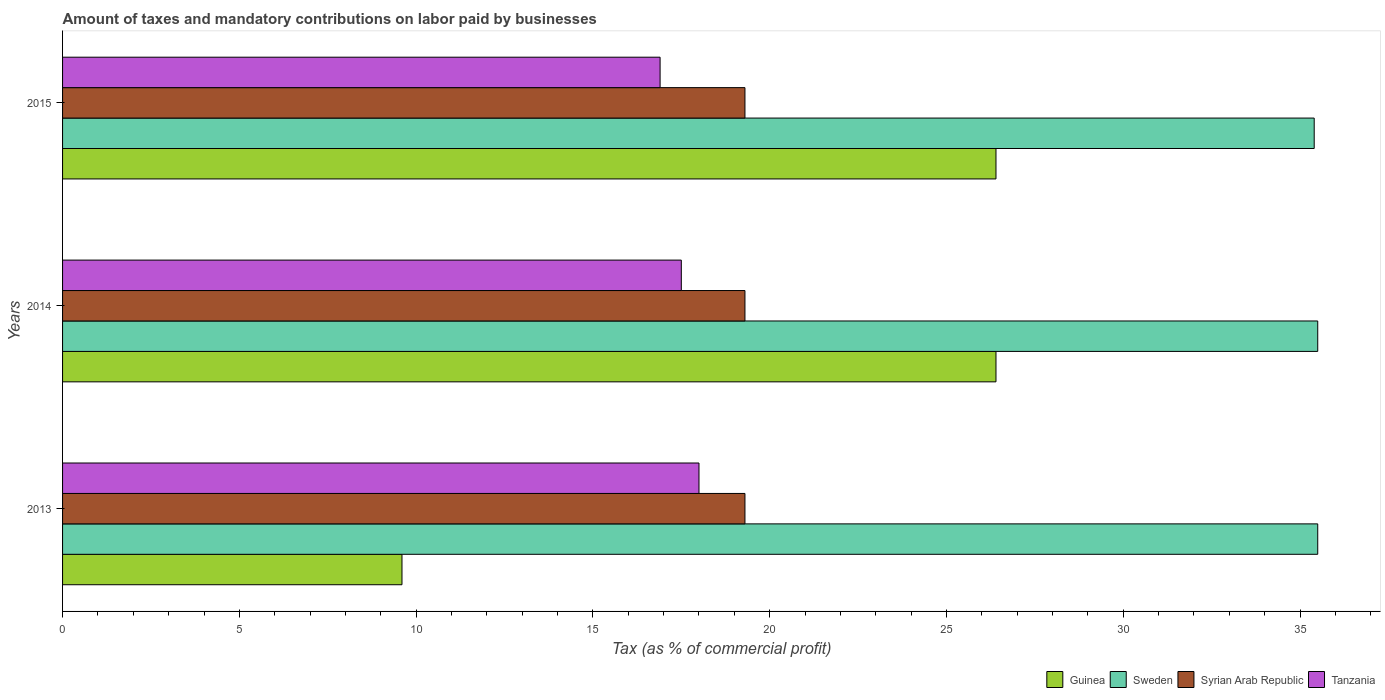How many different coloured bars are there?
Provide a short and direct response. 4. How many groups of bars are there?
Your response must be concise. 3. Are the number of bars on each tick of the Y-axis equal?
Ensure brevity in your answer.  Yes. How many bars are there on the 1st tick from the top?
Offer a very short reply. 4. How many bars are there on the 3rd tick from the bottom?
Your answer should be compact. 4. What is the percentage of taxes paid by businesses in Guinea in 2014?
Provide a short and direct response. 26.4. Across all years, what is the maximum percentage of taxes paid by businesses in Guinea?
Keep it short and to the point. 26.4. In which year was the percentage of taxes paid by businesses in Guinea maximum?
Make the answer very short. 2014. In which year was the percentage of taxes paid by businesses in Guinea minimum?
Your response must be concise. 2013. What is the total percentage of taxes paid by businesses in Syrian Arab Republic in the graph?
Keep it short and to the point. 57.9. What is the difference between the percentage of taxes paid by businesses in Syrian Arab Republic in 2014 and the percentage of taxes paid by businesses in Guinea in 2013?
Your response must be concise. 9.7. What is the average percentage of taxes paid by businesses in Sweden per year?
Give a very brief answer. 35.47. In the year 2013, what is the difference between the percentage of taxes paid by businesses in Syrian Arab Republic and percentage of taxes paid by businesses in Sweden?
Provide a short and direct response. -16.2. In how many years, is the percentage of taxes paid by businesses in Sweden greater than 32 %?
Offer a terse response. 3. What is the ratio of the percentage of taxes paid by businesses in Sweden in 2013 to that in 2015?
Make the answer very short. 1. Is the difference between the percentage of taxes paid by businesses in Syrian Arab Republic in 2013 and 2015 greater than the difference between the percentage of taxes paid by businesses in Sweden in 2013 and 2015?
Your answer should be very brief. No. What is the difference between the highest and the second highest percentage of taxes paid by businesses in Tanzania?
Your answer should be compact. 0.5. What is the difference between the highest and the lowest percentage of taxes paid by businesses in Sweden?
Give a very brief answer. 0.1. Is the sum of the percentage of taxes paid by businesses in Syrian Arab Republic in 2013 and 2015 greater than the maximum percentage of taxes paid by businesses in Guinea across all years?
Your answer should be very brief. Yes. What does the 1st bar from the top in 2015 represents?
Your answer should be very brief. Tanzania. What does the 1st bar from the bottom in 2014 represents?
Ensure brevity in your answer.  Guinea. Is it the case that in every year, the sum of the percentage of taxes paid by businesses in Tanzania and percentage of taxes paid by businesses in Syrian Arab Republic is greater than the percentage of taxes paid by businesses in Sweden?
Offer a very short reply. Yes. How many bars are there?
Your response must be concise. 12. Are all the bars in the graph horizontal?
Make the answer very short. Yes. How many years are there in the graph?
Ensure brevity in your answer.  3. What is the difference between two consecutive major ticks on the X-axis?
Provide a succinct answer. 5. Are the values on the major ticks of X-axis written in scientific E-notation?
Keep it short and to the point. No. Does the graph contain any zero values?
Make the answer very short. No. How many legend labels are there?
Your answer should be compact. 4. How are the legend labels stacked?
Make the answer very short. Horizontal. What is the title of the graph?
Provide a succinct answer. Amount of taxes and mandatory contributions on labor paid by businesses. What is the label or title of the X-axis?
Your answer should be compact. Tax (as % of commercial profit). What is the Tax (as % of commercial profit) in Guinea in 2013?
Your answer should be compact. 9.6. What is the Tax (as % of commercial profit) in Sweden in 2013?
Offer a terse response. 35.5. What is the Tax (as % of commercial profit) of Syrian Arab Republic in 2013?
Keep it short and to the point. 19.3. What is the Tax (as % of commercial profit) in Tanzania in 2013?
Make the answer very short. 18. What is the Tax (as % of commercial profit) in Guinea in 2014?
Ensure brevity in your answer.  26.4. What is the Tax (as % of commercial profit) of Sweden in 2014?
Your answer should be compact. 35.5. What is the Tax (as % of commercial profit) of Syrian Arab Republic in 2014?
Provide a succinct answer. 19.3. What is the Tax (as % of commercial profit) in Tanzania in 2014?
Keep it short and to the point. 17.5. What is the Tax (as % of commercial profit) in Guinea in 2015?
Offer a terse response. 26.4. What is the Tax (as % of commercial profit) in Sweden in 2015?
Your response must be concise. 35.4. What is the Tax (as % of commercial profit) of Syrian Arab Republic in 2015?
Give a very brief answer. 19.3. Across all years, what is the maximum Tax (as % of commercial profit) in Guinea?
Your answer should be very brief. 26.4. Across all years, what is the maximum Tax (as % of commercial profit) in Sweden?
Keep it short and to the point. 35.5. Across all years, what is the maximum Tax (as % of commercial profit) of Syrian Arab Republic?
Keep it short and to the point. 19.3. Across all years, what is the minimum Tax (as % of commercial profit) of Sweden?
Offer a terse response. 35.4. Across all years, what is the minimum Tax (as % of commercial profit) of Syrian Arab Republic?
Offer a terse response. 19.3. Across all years, what is the minimum Tax (as % of commercial profit) in Tanzania?
Offer a terse response. 16.9. What is the total Tax (as % of commercial profit) in Guinea in the graph?
Your response must be concise. 62.4. What is the total Tax (as % of commercial profit) of Sweden in the graph?
Make the answer very short. 106.4. What is the total Tax (as % of commercial profit) in Syrian Arab Republic in the graph?
Provide a short and direct response. 57.9. What is the total Tax (as % of commercial profit) in Tanzania in the graph?
Provide a short and direct response. 52.4. What is the difference between the Tax (as % of commercial profit) of Guinea in 2013 and that in 2014?
Offer a very short reply. -16.8. What is the difference between the Tax (as % of commercial profit) in Sweden in 2013 and that in 2014?
Provide a short and direct response. 0. What is the difference between the Tax (as % of commercial profit) of Syrian Arab Republic in 2013 and that in 2014?
Ensure brevity in your answer.  0. What is the difference between the Tax (as % of commercial profit) in Guinea in 2013 and that in 2015?
Your answer should be compact. -16.8. What is the difference between the Tax (as % of commercial profit) in Tanzania in 2013 and that in 2015?
Provide a succinct answer. 1.1. What is the difference between the Tax (as % of commercial profit) of Syrian Arab Republic in 2014 and that in 2015?
Provide a succinct answer. 0. What is the difference between the Tax (as % of commercial profit) of Tanzania in 2014 and that in 2015?
Your answer should be very brief. 0.6. What is the difference between the Tax (as % of commercial profit) of Guinea in 2013 and the Tax (as % of commercial profit) of Sweden in 2014?
Your response must be concise. -25.9. What is the difference between the Tax (as % of commercial profit) in Guinea in 2013 and the Tax (as % of commercial profit) in Syrian Arab Republic in 2014?
Provide a succinct answer. -9.7. What is the difference between the Tax (as % of commercial profit) of Sweden in 2013 and the Tax (as % of commercial profit) of Tanzania in 2014?
Provide a short and direct response. 18. What is the difference between the Tax (as % of commercial profit) of Syrian Arab Republic in 2013 and the Tax (as % of commercial profit) of Tanzania in 2014?
Provide a succinct answer. 1.8. What is the difference between the Tax (as % of commercial profit) of Guinea in 2013 and the Tax (as % of commercial profit) of Sweden in 2015?
Your response must be concise. -25.8. What is the difference between the Tax (as % of commercial profit) of Guinea in 2013 and the Tax (as % of commercial profit) of Syrian Arab Republic in 2015?
Offer a terse response. -9.7. What is the difference between the Tax (as % of commercial profit) of Guinea in 2013 and the Tax (as % of commercial profit) of Tanzania in 2015?
Provide a short and direct response. -7.3. What is the difference between the Tax (as % of commercial profit) in Sweden in 2013 and the Tax (as % of commercial profit) in Syrian Arab Republic in 2015?
Keep it short and to the point. 16.2. What is the difference between the Tax (as % of commercial profit) of Syrian Arab Republic in 2013 and the Tax (as % of commercial profit) of Tanzania in 2015?
Keep it short and to the point. 2.4. What is the difference between the Tax (as % of commercial profit) in Sweden in 2014 and the Tax (as % of commercial profit) in Tanzania in 2015?
Your answer should be very brief. 18.6. What is the average Tax (as % of commercial profit) in Guinea per year?
Your answer should be very brief. 20.8. What is the average Tax (as % of commercial profit) in Sweden per year?
Offer a terse response. 35.47. What is the average Tax (as % of commercial profit) in Syrian Arab Republic per year?
Provide a short and direct response. 19.3. What is the average Tax (as % of commercial profit) of Tanzania per year?
Make the answer very short. 17.47. In the year 2013, what is the difference between the Tax (as % of commercial profit) of Guinea and Tax (as % of commercial profit) of Sweden?
Provide a short and direct response. -25.9. In the year 2013, what is the difference between the Tax (as % of commercial profit) in Guinea and Tax (as % of commercial profit) in Tanzania?
Your answer should be very brief. -8.4. In the year 2013, what is the difference between the Tax (as % of commercial profit) in Sweden and Tax (as % of commercial profit) in Syrian Arab Republic?
Your answer should be compact. 16.2. In the year 2014, what is the difference between the Tax (as % of commercial profit) in Guinea and Tax (as % of commercial profit) in Sweden?
Give a very brief answer. -9.1. In the year 2014, what is the difference between the Tax (as % of commercial profit) in Sweden and Tax (as % of commercial profit) in Tanzania?
Provide a short and direct response. 18. In the year 2014, what is the difference between the Tax (as % of commercial profit) of Syrian Arab Republic and Tax (as % of commercial profit) of Tanzania?
Your answer should be very brief. 1.8. In the year 2015, what is the difference between the Tax (as % of commercial profit) of Sweden and Tax (as % of commercial profit) of Syrian Arab Republic?
Offer a terse response. 16.1. What is the ratio of the Tax (as % of commercial profit) in Guinea in 2013 to that in 2014?
Ensure brevity in your answer.  0.36. What is the ratio of the Tax (as % of commercial profit) of Sweden in 2013 to that in 2014?
Ensure brevity in your answer.  1. What is the ratio of the Tax (as % of commercial profit) in Tanzania in 2013 to that in 2014?
Provide a short and direct response. 1.03. What is the ratio of the Tax (as % of commercial profit) in Guinea in 2013 to that in 2015?
Your response must be concise. 0.36. What is the ratio of the Tax (as % of commercial profit) of Tanzania in 2013 to that in 2015?
Provide a succinct answer. 1.07. What is the ratio of the Tax (as % of commercial profit) in Guinea in 2014 to that in 2015?
Offer a terse response. 1. What is the ratio of the Tax (as % of commercial profit) of Sweden in 2014 to that in 2015?
Your response must be concise. 1. What is the ratio of the Tax (as % of commercial profit) in Tanzania in 2014 to that in 2015?
Your answer should be compact. 1.04. What is the difference between the highest and the second highest Tax (as % of commercial profit) in Syrian Arab Republic?
Your answer should be compact. 0. What is the difference between the highest and the second highest Tax (as % of commercial profit) of Tanzania?
Give a very brief answer. 0.5. What is the difference between the highest and the lowest Tax (as % of commercial profit) of Sweden?
Your answer should be very brief. 0.1. What is the difference between the highest and the lowest Tax (as % of commercial profit) in Syrian Arab Republic?
Your answer should be compact. 0. What is the difference between the highest and the lowest Tax (as % of commercial profit) of Tanzania?
Your response must be concise. 1.1. 